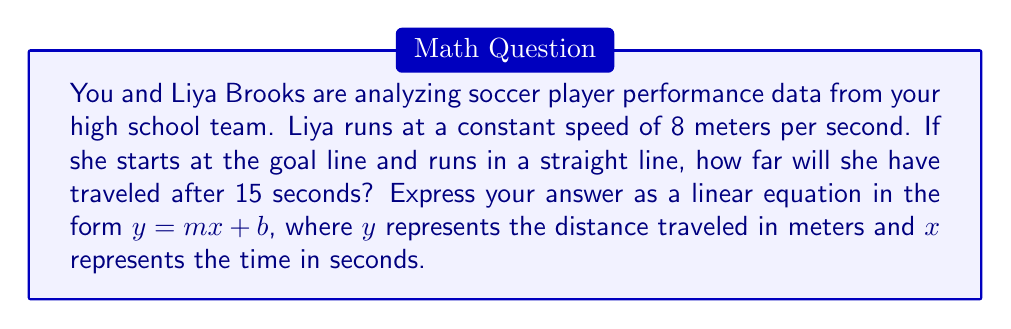Help me with this question. To solve this problem, we need to use the concept of linear equations and the relationship between speed, distance, and time.

1) First, recall the formula for speed:
   $\text{Speed} = \frac{\text{Distance}}{\text{Time}}$

2) We're given that Liya's speed is constant at 8 meters per second. Let's call distance $y$ and time $x$. We can rewrite the speed formula as:

   $8 = \frac{y}{x}$

3) To get this into the form of a linear equation ($y = mx + b$), multiply both sides by $x$:

   $8x = y$

4) In this case, the slope $m$ is 8, representing Liya's speed in meters per second.

5) Since Liya starts at the goal line, her initial distance is 0 meters. This means the y-intercept $b$ is 0.

6) Therefore, the linear equation representing Liya's distance traveled over time is:

   $y = 8x + 0$, which simplifies to $y = 8x$

7) To check our work, we can calculate the distance after 15 seconds:
   $y = 8(15) = 120$ meters

This matches what we'd expect: running at 8 meters per second for 15 seconds should cover 120 meters.
Answer: $y = 8x$ 